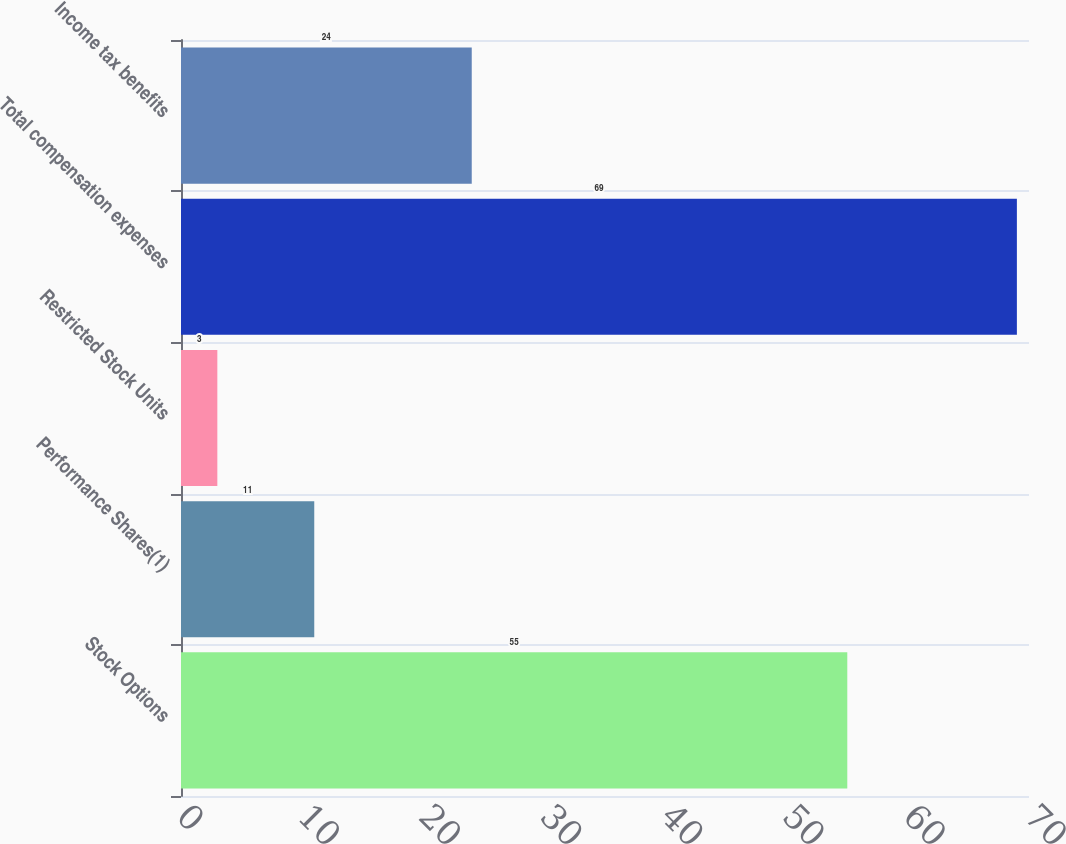Convert chart to OTSL. <chart><loc_0><loc_0><loc_500><loc_500><bar_chart><fcel>Stock Options<fcel>Performance Shares(1)<fcel>Restricted Stock Units<fcel>Total compensation expenses<fcel>Income tax benefits<nl><fcel>55<fcel>11<fcel>3<fcel>69<fcel>24<nl></chart> 